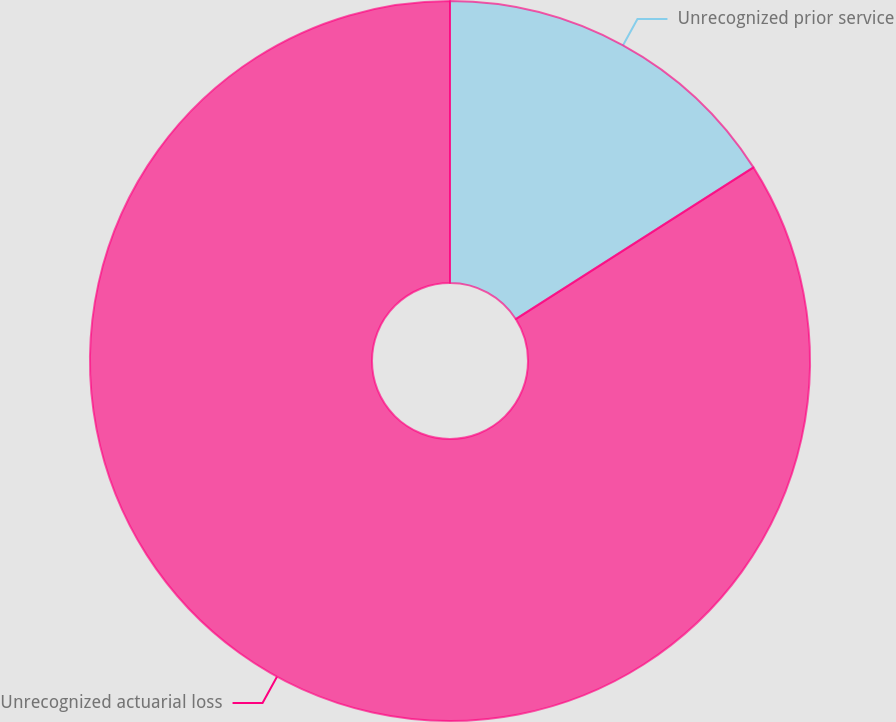Convert chart to OTSL. <chart><loc_0><loc_0><loc_500><loc_500><pie_chart><fcel>Unrecognized prior service<fcel>Unrecognized actuarial loss<nl><fcel>15.96%<fcel>84.04%<nl></chart> 